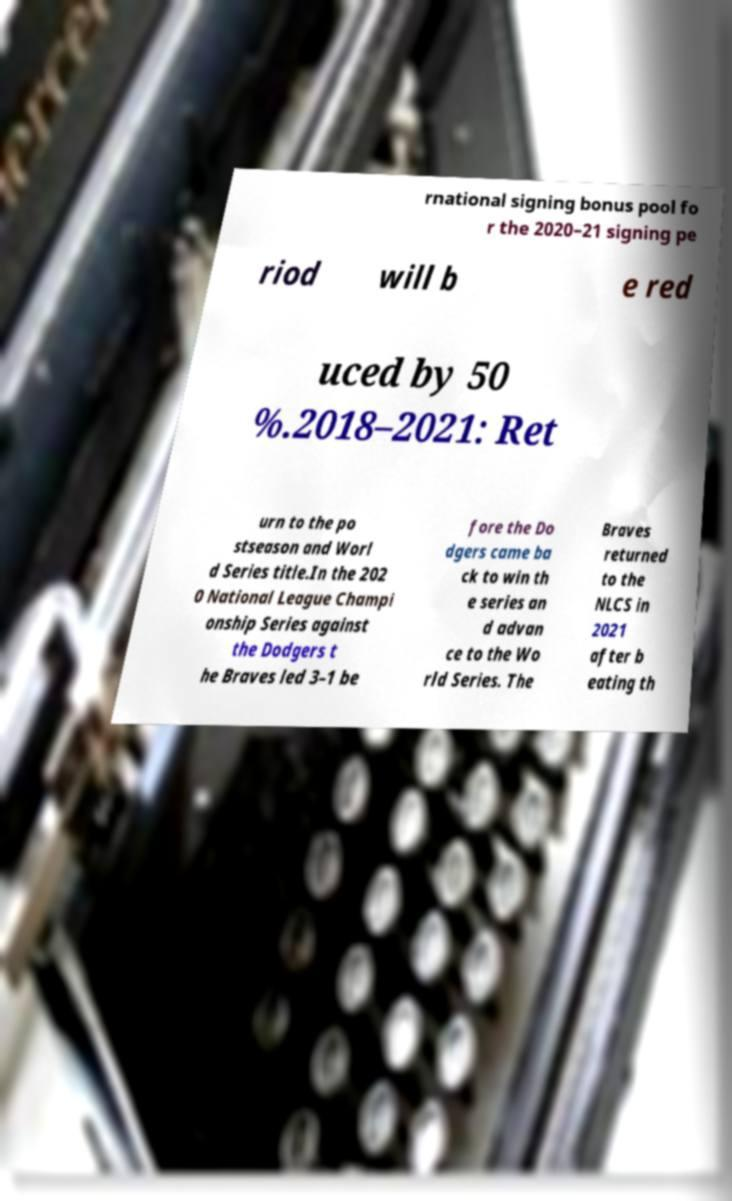Please identify and transcribe the text found in this image. rnational signing bonus pool fo r the 2020–21 signing pe riod will b e red uced by 50 %.2018–2021: Ret urn to the po stseason and Worl d Series title.In the 202 0 National League Champi onship Series against the Dodgers t he Braves led 3–1 be fore the Do dgers came ba ck to win th e series an d advan ce to the Wo rld Series. The Braves returned to the NLCS in 2021 after b eating th 